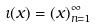Convert formula to latex. <formula><loc_0><loc_0><loc_500><loc_500>\iota ( x ) = ( x ) _ { n = 1 } ^ { \infty }</formula> 